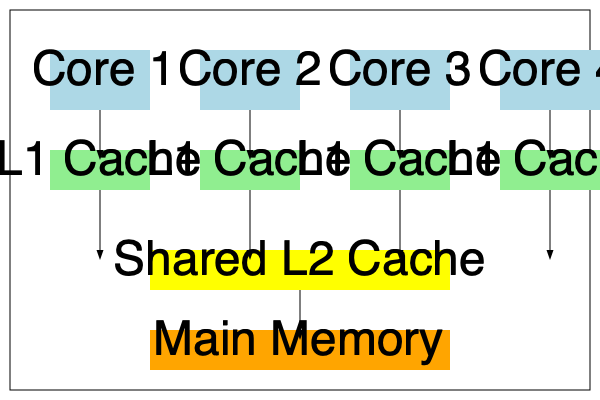In the context of the multi-core system depicted in the diagram, explain how cache coherence protocols impact the performance of multi-threaded Scala applications. Specifically, discuss the trade-offs between maintaining cache coherence and optimizing parallel execution in terms of memory access latency and inter-core communication overhead. To understand the impact of cache coherence protocols on multi-threaded Scala applications in a multi-core system, let's analyze the diagram step-by-step:

1. System Architecture:
   The diagram shows a quad-core processor with private L1 caches for each core, a shared L2 cache, and main memory.

2. Cache Coherence Problem:
   In multi-core systems, each core has its own private cache (L1). When multiple cores access and modify the same data, inconsistencies can arise between the copies in different caches.

3. Cache Coherence Protocols:
   These protocols ensure that all cores have a consistent view of shared data. Common protocols include MESI (Modified, Exclusive, Shared, Invalid) and MOESI.

4. Impact on Scala Applications:
   a. Memory Access Latency:
      - Positive: Cache coherence allows cores to access data from nearby caches, reducing latency compared to main memory access.
      - Negative: Maintaining coherence can introduce additional latency due to cache-to-cache transfers and invalidation messages.

   b. Inter-core Communication:
      - Coherence protocols increase inter-core communication, which can lead to increased traffic on the interconnect.

   c. Parallel Execution:
      - Positive: Enables efficient sharing of data between threads running on different cores.
      - Negative: Can lead to false sharing, where cores invalidate each other's cache lines even when accessing different variables.

5. Performance Considerations:
   a. Scala's immutable data structures can help reduce coherence traffic by minimizing shared mutable state.
   b. Proper data partitioning and thread affinity can improve cache usage and reduce coherence overhead.
   c. Balancing work distribution across cores is crucial to maximize parallel execution while minimizing coherence-related bottlenecks.

6. Trade-offs:
   a. Aggressive coherence protocols ensure strong consistency but may introduce higher overhead.
   b. Relaxed consistency models can improve performance but require careful programming to avoid race conditions.

7. Optimization Strategies:
   a. Use of concurrent data structures optimized for multi-core systems.
   b. Implementing fine-grained locking or lock-free algorithms to reduce contention.
   c. Leveraging Scala's actor model (e.g., Akka) to minimize shared mutable state.

In conclusion, while cache coherence protocols are essential for correct execution of multi-threaded Scala applications on multi-core systems, they introduce performance trade-offs. Optimizing performance requires careful consideration of data sharing patterns, memory access patterns, and the specific characteristics of the underlying hardware and coherence protocol.
Answer: Cache coherence protocols ensure data consistency across cores but introduce performance trade-offs in multi-threaded Scala applications, affecting memory access latency and inter-core communication overhead. Optimization requires balancing coherence maintenance with efficient parallel execution through proper data partitioning, minimizing shared mutable state, and leveraging Scala-specific concurrency features. 